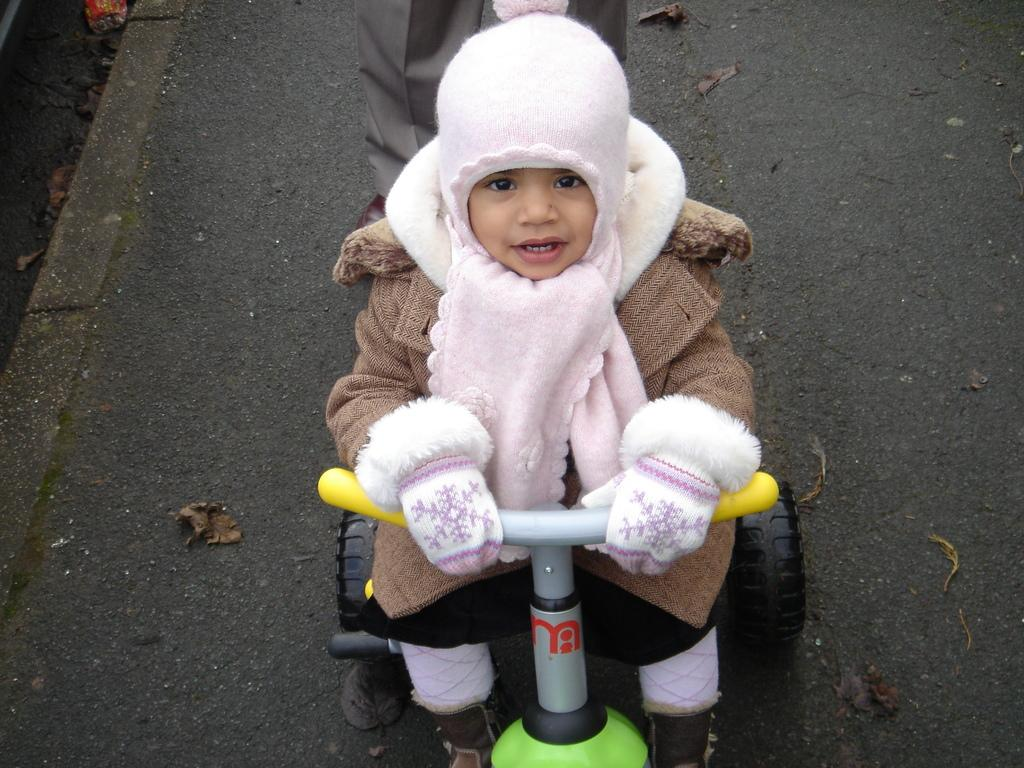Who is the main subject in the image? There is a child in the image. What is the child doing in the image? The child is sitting on a baby cycle. Are there any other people visible in the image? Yes, there is a person standing on the road in the image. What type of plastic material is being crushed by the child in the image? There is no plastic material being crushed in the image; the child is sitting on a baby cycle. 